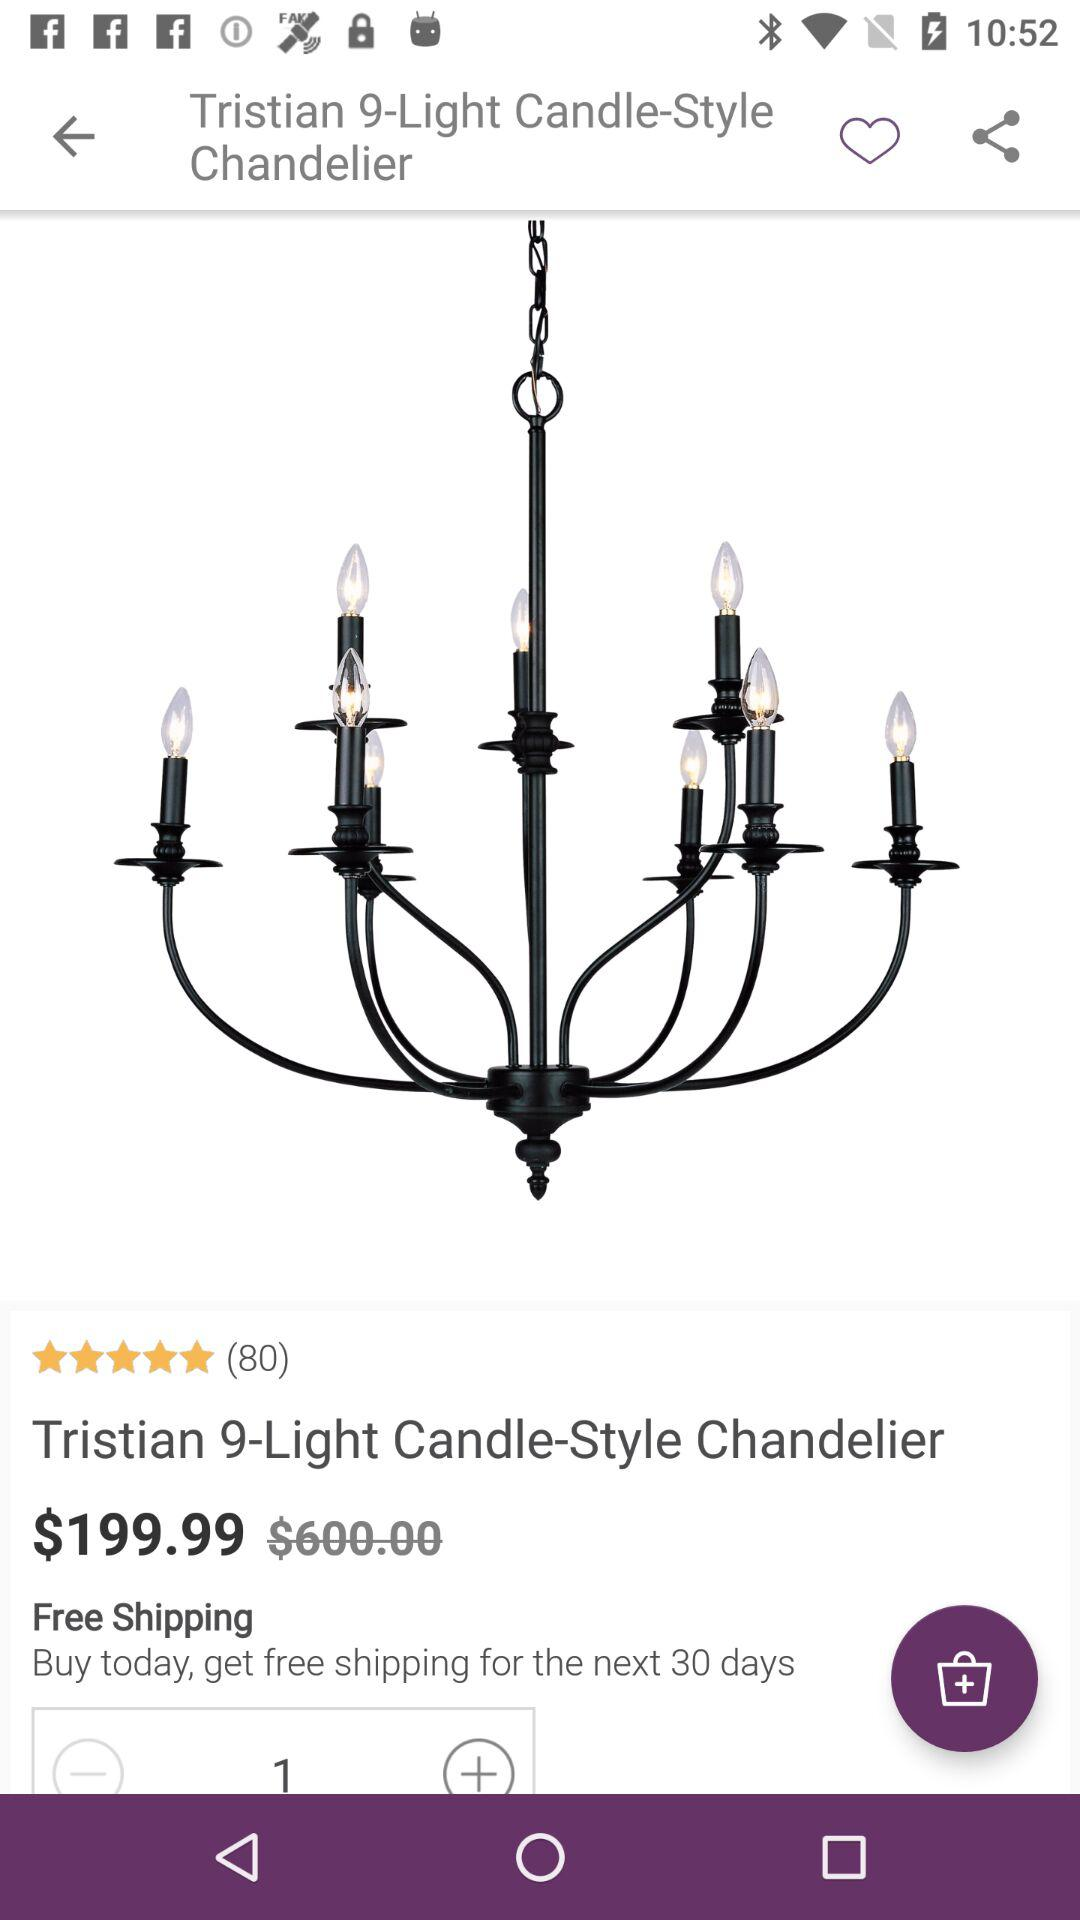What is the name of the product? The name of the product is "Tristian 9-Light Candle-Style Chandelier". 